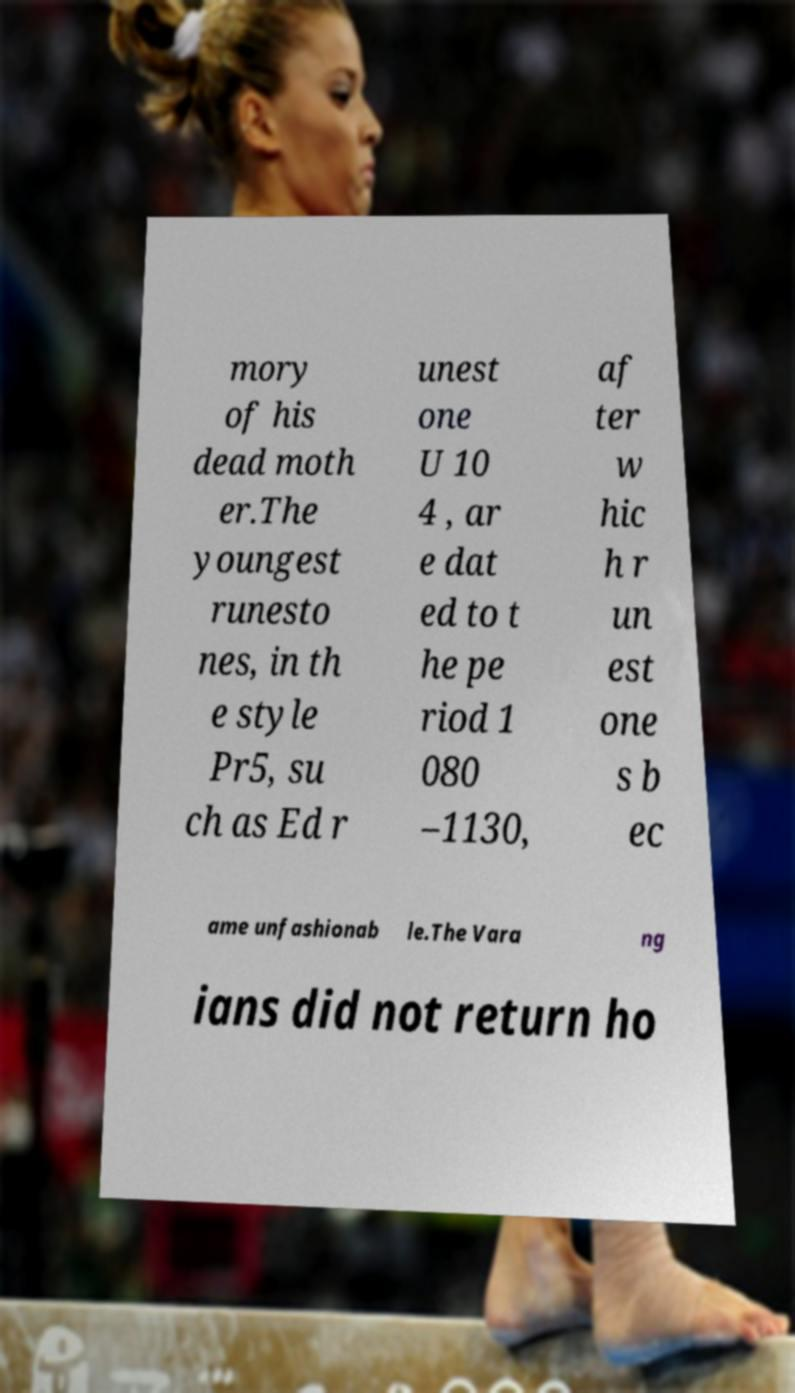Could you assist in decoding the text presented in this image and type it out clearly? mory of his dead moth er.The youngest runesto nes, in th e style Pr5, su ch as Ed r unest one U 10 4 , ar e dat ed to t he pe riod 1 080 –1130, af ter w hic h r un est one s b ec ame unfashionab le.The Vara ng ians did not return ho 